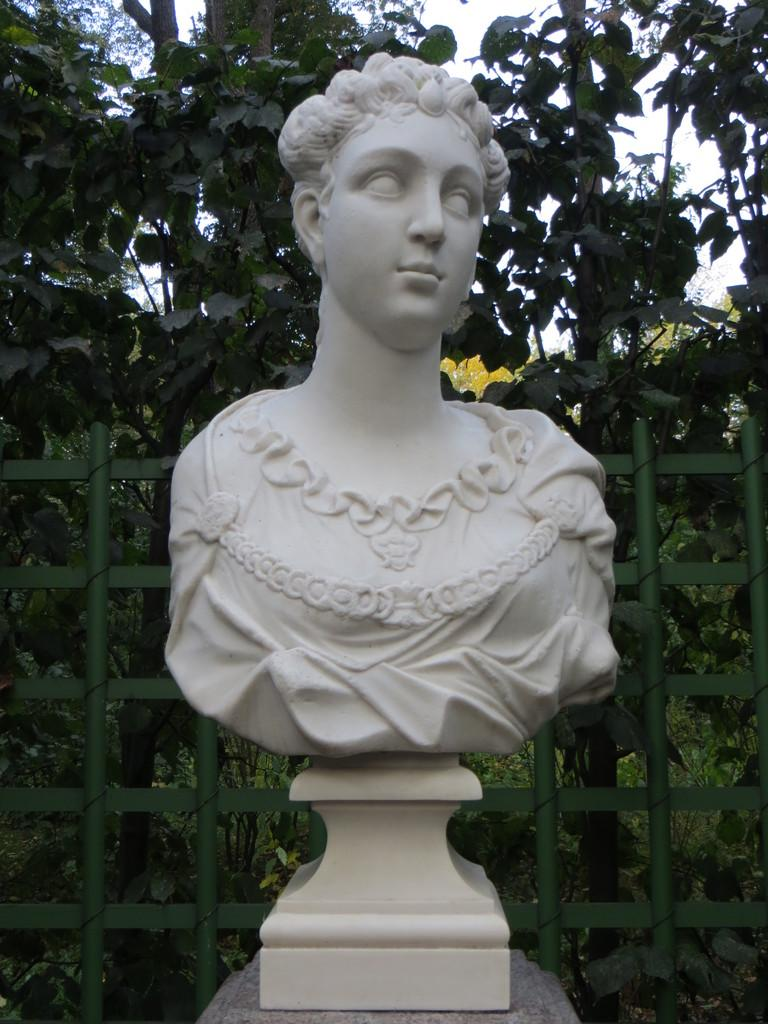What is the main subject of the image? There is a statue of a person in the image. What is located behind the person in the image? There is a fencing behind the person. What can be seen behind the fencing in the image? There are plants with leaves behind the fencing. How many nails can be seen holding the statue together in the image? There are no visible nails holding the statue together in the image. Is there a horse present in the image during a rainstorm? There is no horse or rainstorm present in the image; it features a statue of a person with a fencing and plants with leaves in the background. 